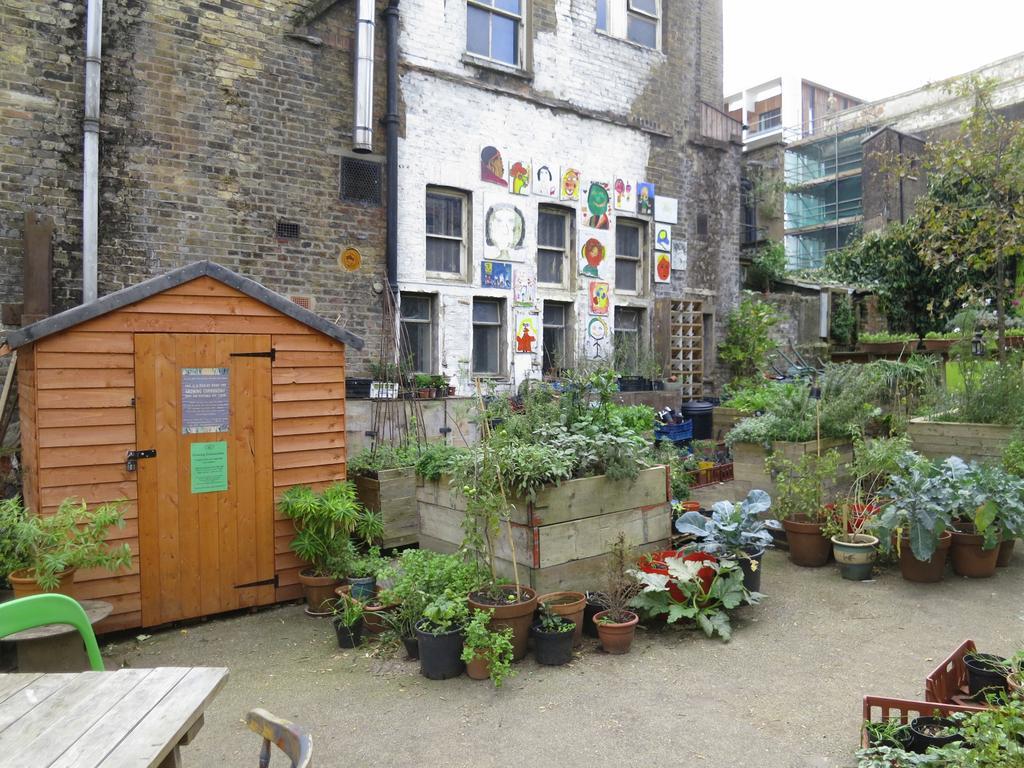Please provide a concise description of this image. In this image I can see number of plants. I can also see few chairs, a table, a shack and few buildings. 